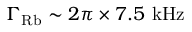Convert formula to latex. <formula><loc_0><loc_0><loc_500><loc_500>\Gamma _ { R b } \sim 2 \pi \times 7 . 5 k H z</formula> 